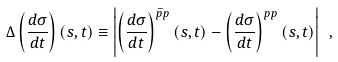<formula> <loc_0><loc_0><loc_500><loc_500>\Delta \left ( \frac { d \sigma } { d t } \right ) ( s , t ) \equiv \left | \left ( \frac { d \sigma } { d t } \right ) ^ { \bar { p } p } ( s , t ) - \left ( \frac { d \sigma } { d t } \right ) ^ { p p } ( s , t ) \right | \ ,</formula> 